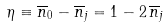<formula> <loc_0><loc_0><loc_500><loc_500>\eta \equiv \overline { n } _ { 0 } - \overline { n } _ { j } = 1 - 2 \, \overline { n } _ { j }</formula> 